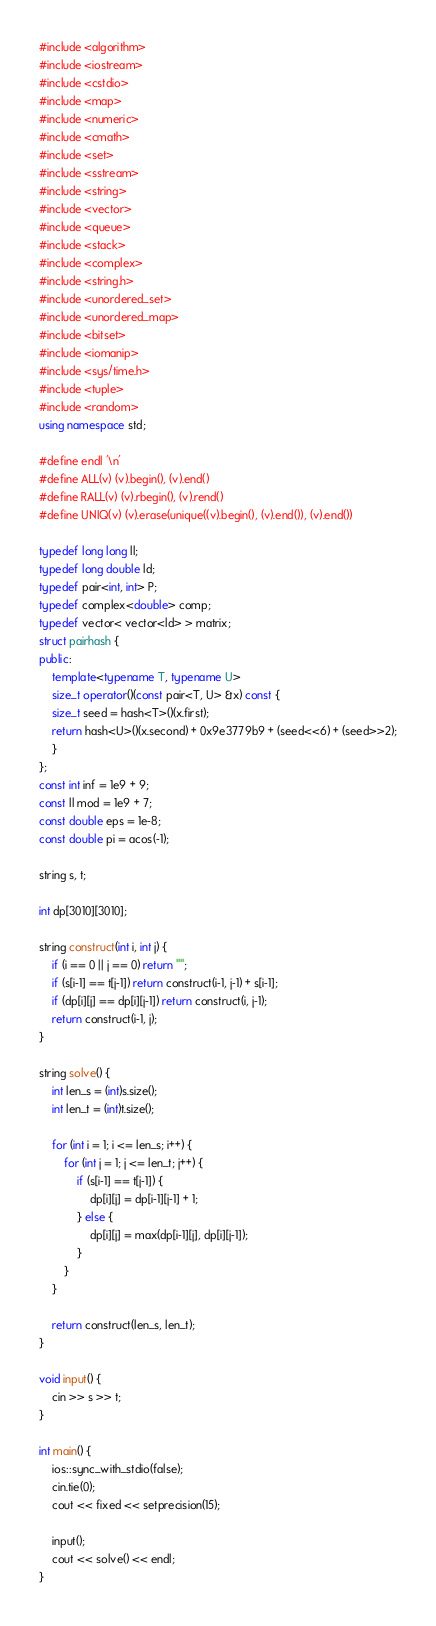<code> <loc_0><loc_0><loc_500><loc_500><_C++_>#include <algorithm>
#include <iostream>
#include <cstdio>
#include <map>
#include <numeric>
#include <cmath>
#include <set>
#include <sstream>
#include <string>
#include <vector>
#include <queue>
#include <stack>
#include <complex>
#include <string.h>
#include <unordered_set>
#include <unordered_map>
#include <bitset>
#include <iomanip>
#include <sys/time.h>
#include <tuple>
#include <random>
using namespace std;

#define endl '\n'
#define ALL(v) (v).begin(), (v).end()
#define RALL(v) (v).rbegin(), (v).rend()
#define UNIQ(v) (v).erase(unique((v).begin(), (v).end()), (v).end())

typedef long long ll;
typedef long double ld;
typedef pair<int, int> P;
typedef complex<double> comp;
typedef vector< vector<ld> > matrix;
struct pairhash {
public:
    template<typename T, typename U>
    size_t operator()(const pair<T, U> &x) const {
	size_t seed = hash<T>()(x.first);
	return hash<U>()(x.second) + 0x9e3779b9 + (seed<<6) + (seed>>2);
    }
};
const int inf = 1e9 + 9;
const ll mod = 1e9 + 7;
const double eps = 1e-8;
const double pi = acos(-1);

string s, t;

int dp[3010][3010];

string construct(int i, int j) {
    if (i == 0 || j == 0) return "";
    if (s[i-1] == t[j-1]) return construct(i-1, j-1) + s[i-1];
    if (dp[i][j] == dp[i][j-1]) return construct(i, j-1);
    return construct(i-1, j);
}

string solve() {
    int len_s = (int)s.size();
    int len_t = (int)t.size();

    for (int i = 1; i <= len_s; i++) {
        for (int j = 1; j <= len_t; j++) {
            if (s[i-1] == t[j-1]) {
                dp[i][j] = dp[i-1][j-1] + 1;
            } else {
                dp[i][j] = max(dp[i-1][j], dp[i][j-1]);
            }
        }
    }

    return construct(len_s, len_t);
}

void input() {
    cin >> s >> t;
}

int main() {
    ios::sync_with_stdio(false);
    cin.tie(0);
    cout << fixed << setprecision(15);

    input();
    cout << solve() << endl;
}
</code> 